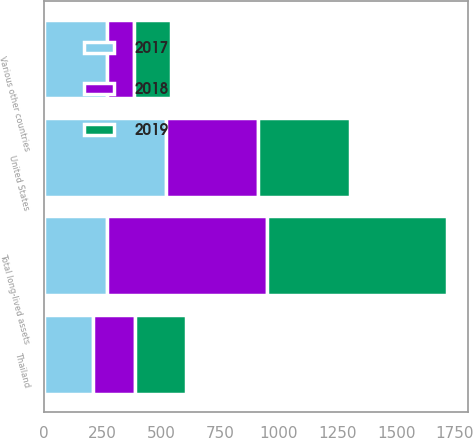Convert chart to OTSL. <chart><loc_0><loc_0><loc_500><loc_500><stacked_bar_chart><ecel><fcel>United States<fcel>Thailand<fcel>Various other countries<fcel>Total long-lived assets<nl><fcel>2017<fcel>521.1<fcel>209.3<fcel>266.3<fcel>266.3<nl><fcel>2019<fcel>393.3<fcel>215.5<fcel>159.1<fcel>767.9<nl><fcel>2018<fcel>388.5<fcel>178<fcel>116.8<fcel>683.3<nl></chart> 